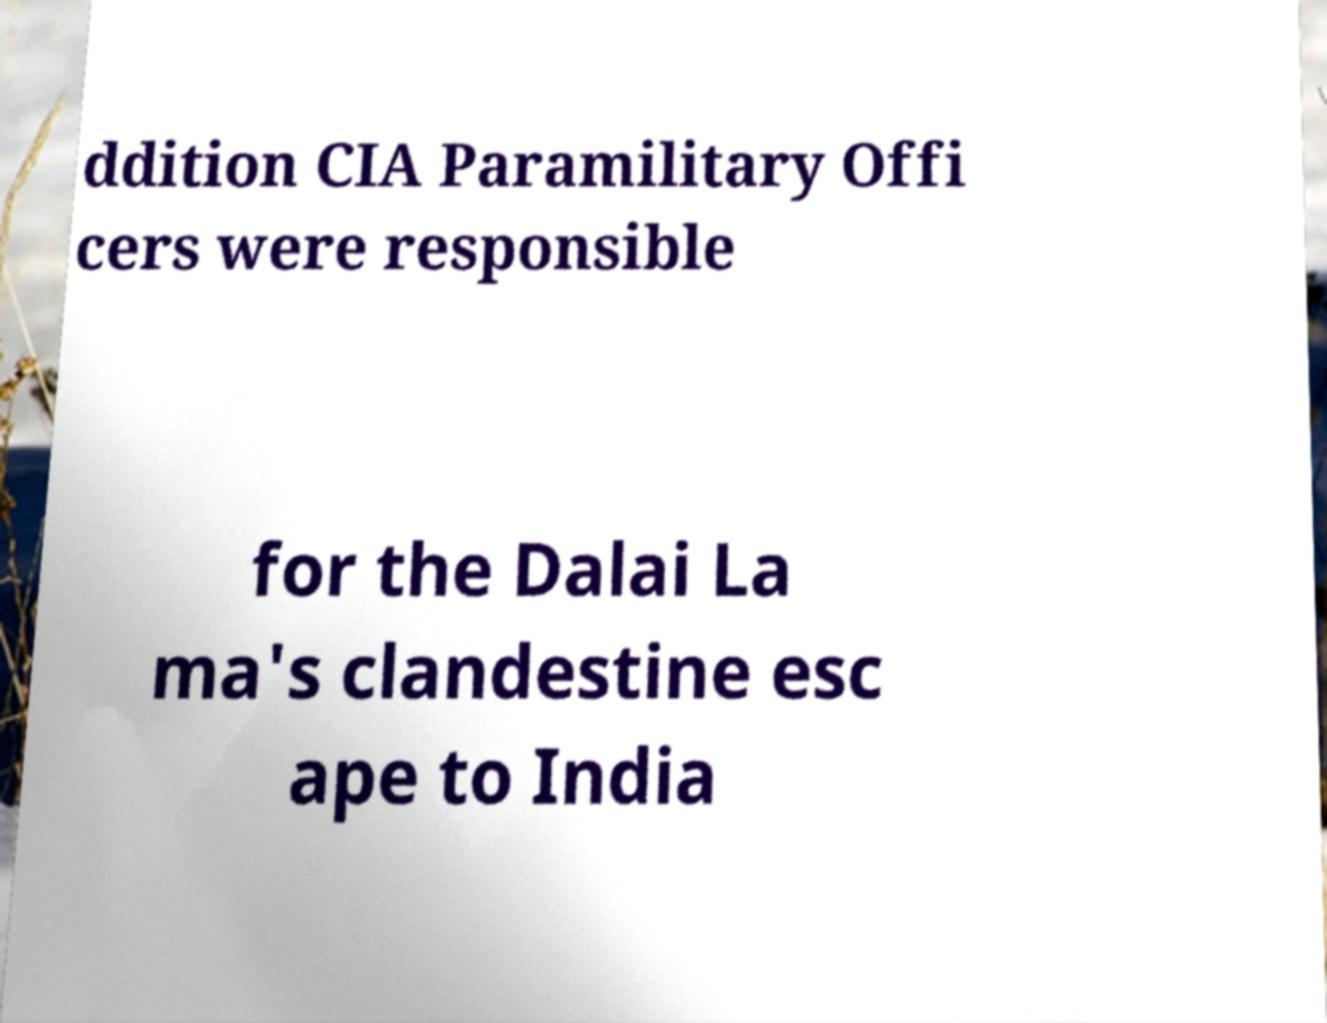Please identify and transcribe the text found in this image. ddition CIA Paramilitary Offi cers were responsible for the Dalai La ma's clandestine esc ape to India 